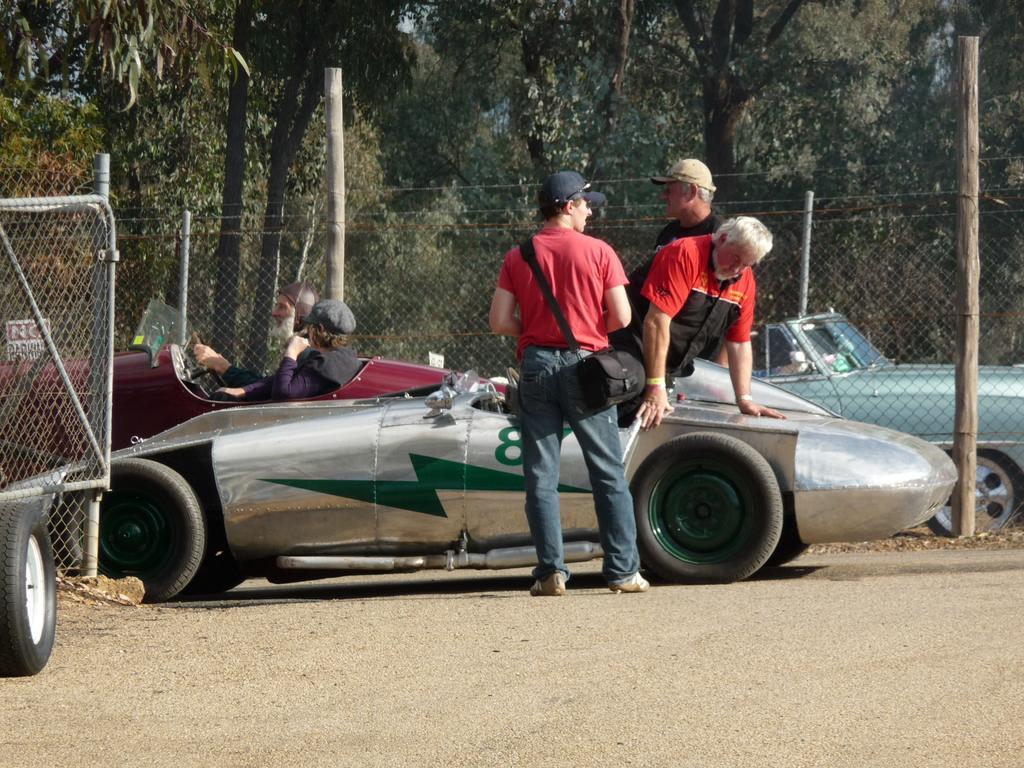Describe this image in one or two sentences. This picture is clicked outside the city. In a ground, we see vehicles parked and we see three men standing near the vehicle. Beside them, we see fence and behind that, see many trees. 